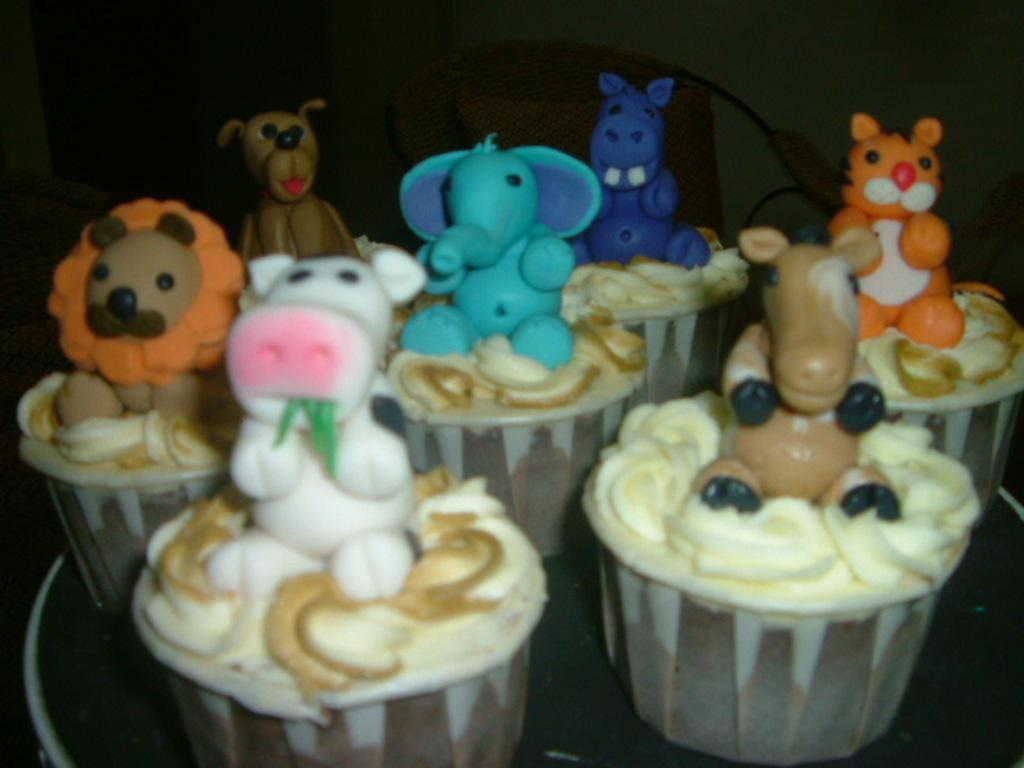What decorations are on the cupcakes in the image? There are gumpaste animals on the cupcakes. What are the cupcakes placed on? The cupcakes are on an object. What piece of furniture is visible behind the cupcakes? There is a chair behind the cupcakes. How would you describe the lighting in the image? The background of the image is dark. What type of fan is visible in the image? There is no fan present in the image. How many dinosaurs can be seen on the cupcakes? There are no dinosaurs on the cupcakes; they are decorated with gumpaste animals. 